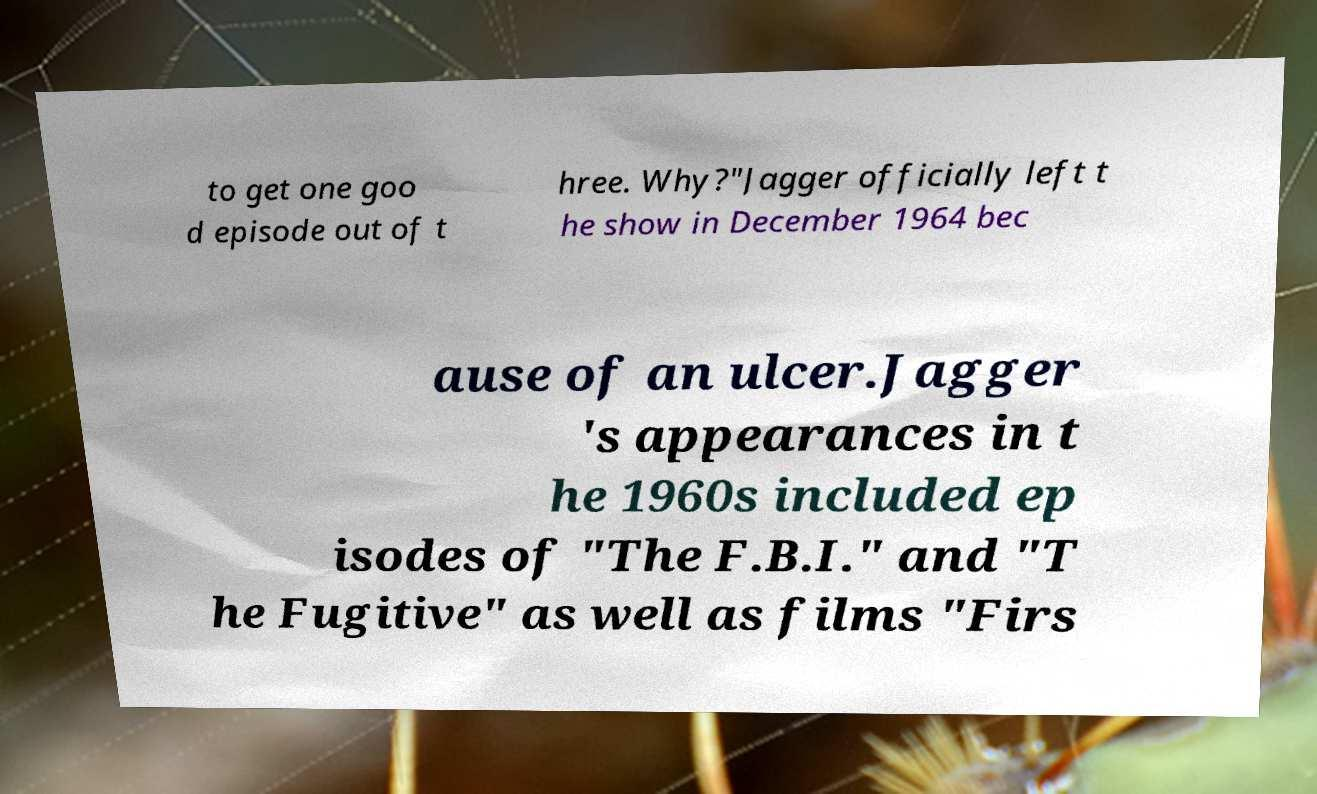There's text embedded in this image that I need extracted. Can you transcribe it verbatim? to get one goo d episode out of t hree. Why?"Jagger officially left t he show in December 1964 bec ause of an ulcer.Jagger 's appearances in t he 1960s included ep isodes of "The F.B.I." and "T he Fugitive" as well as films "Firs 